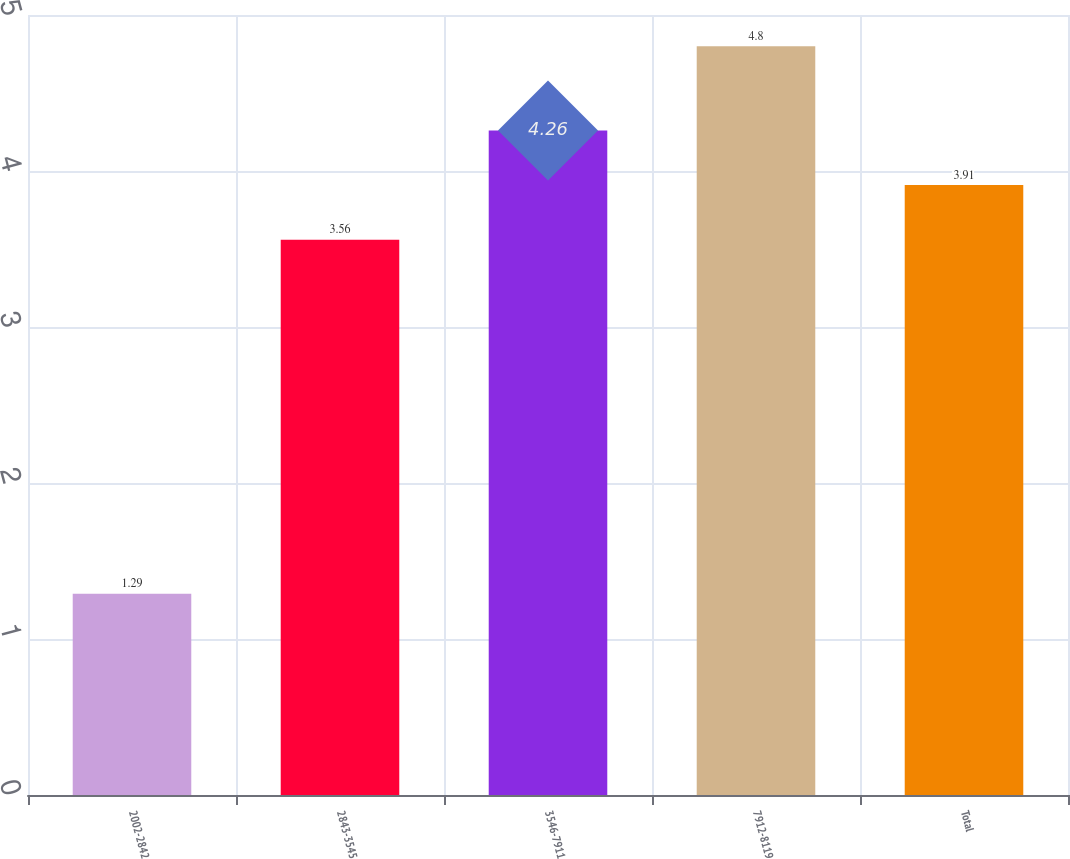Convert chart to OTSL. <chart><loc_0><loc_0><loc_500><loc_500><bar_chart><fcel>2002-2842<fcel>2843-3545<fcel>3546-7911<fcel>7912-8119<fcel>Total<nl><fcel>1.29<fcel>3.56<fcel>4.26<fcel>4.8<fcel>3.91<nl></chart> 